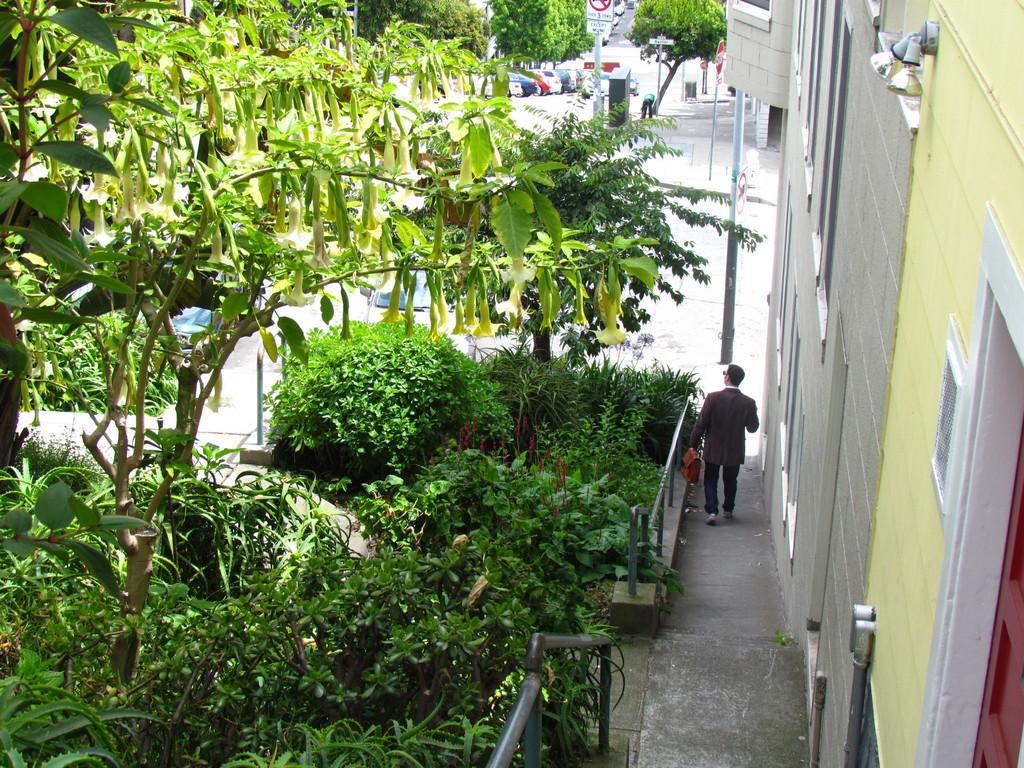In one or two sentences, can you explain what this image depicts? In this picture we can see a building on the right side, on the left side we can see some plants and tree, there is a person walking in the middle, in the background there are some trees, vehicles, poles and boards. 